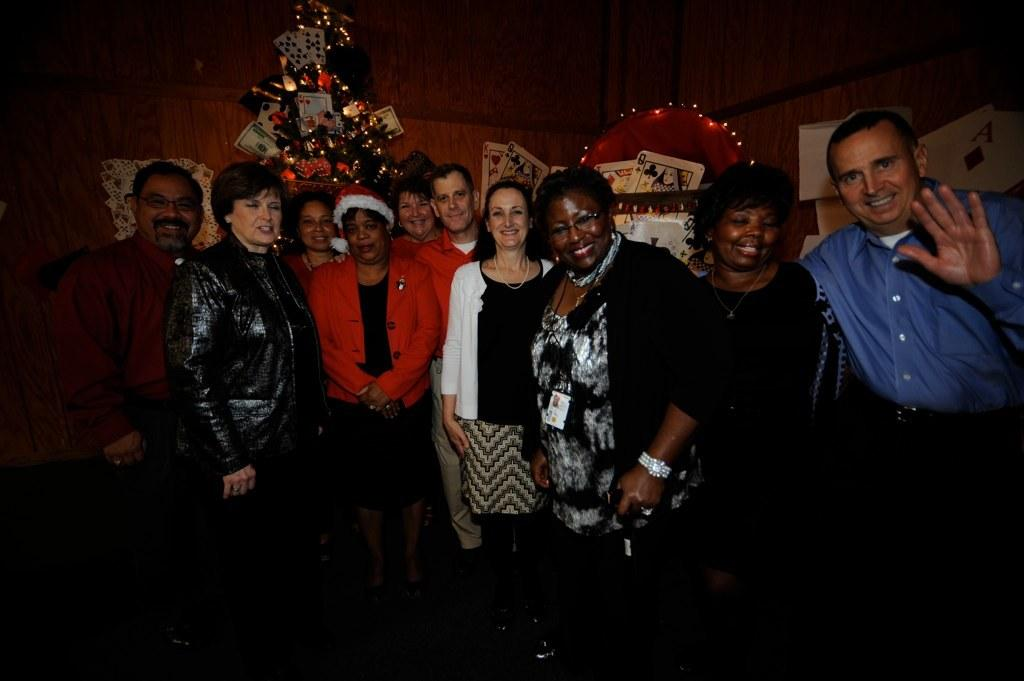What are the people in the image doing? The persons in the image are standing and posing for a camera. What objects can be seen in the image besides the people? There are cards visible in the image. What is in the background of the image? There is a wall in the background of the image. What type of grain is being used to create the cards in the image? There is no indication in the image that the cards are made of grain, so it cannot be determined from the picture. 